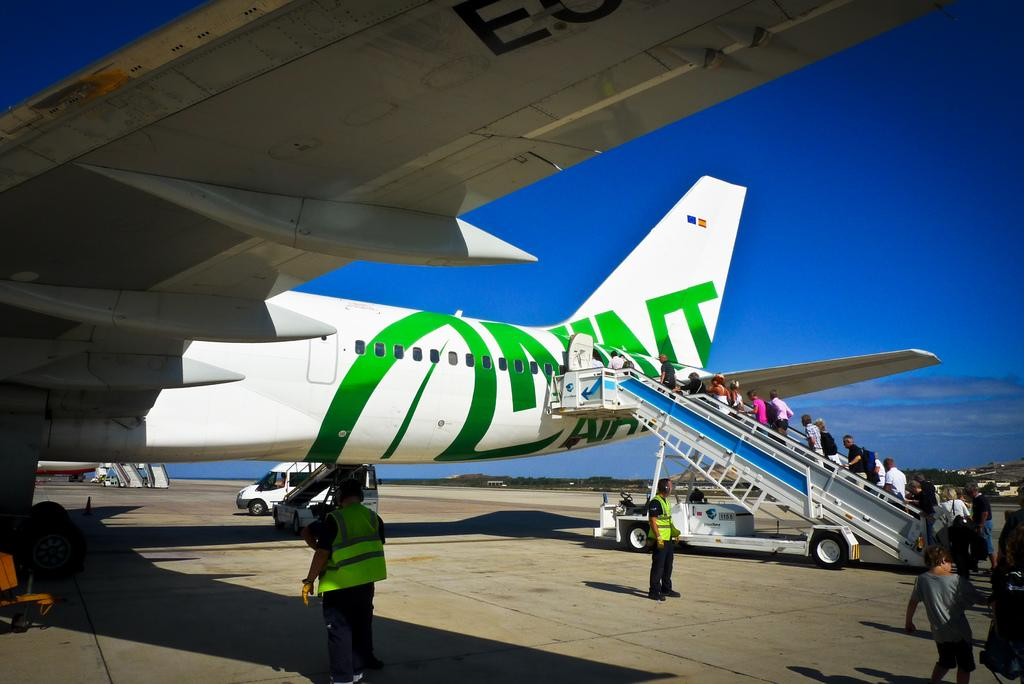<image>
Create a compact narrative representing the image presented. a branded airplane sits on the tarmac, with the lower part of the brand reading AIR 